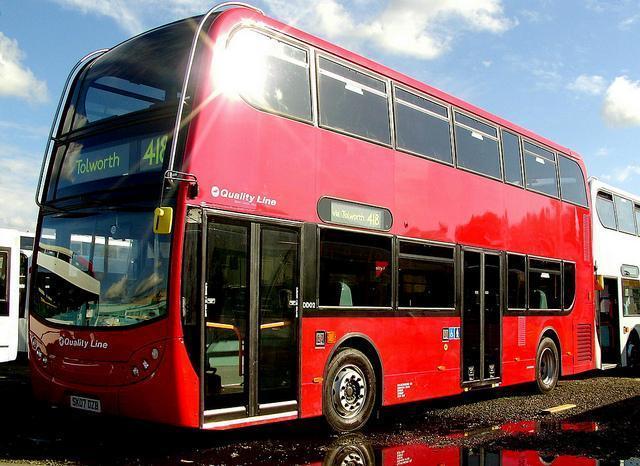How many levels of seating is on this bus?
Give a very brief answer. 2. How many buses are there?
Give a very brief answer. 3. 